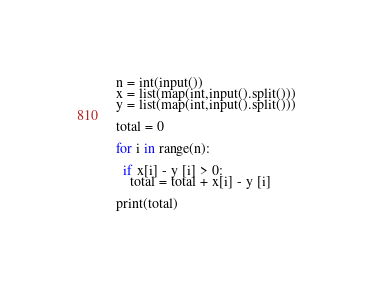Convert code to text. <code><loc_0><loc_0><loc_500><loc_500><_Python_>n = int(input())
x = list(map(int,input().split()))
y = list(map(int,input().split()))

total = 0

for i in range(n):

  if x[i] - y [i] > 0:
    total = total + x[i] - y [i]

print(total)</code> 